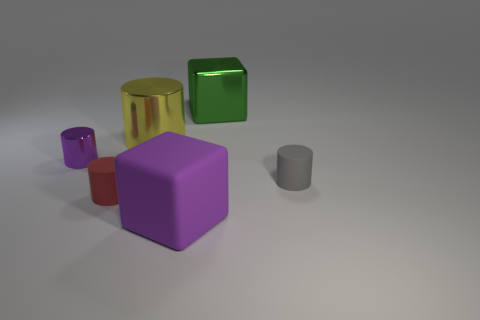What shape is the object that is to the right of the big rubber cube and behind the purple cylinder?
Offer a very short reply. Cube. There is a shiny object to the right of the purple rubber thing; what shape is it?
Your answer should be compact. Cube. How many cylinders are both to the left of the tiny gray matte cylinder and in front of the purple cylinder?
Keep it short and to the point. 1. Is the size of the red rubber cylinder the same as the cube in front of the big green shiny object?
Offer a very short reply. No. What is the size of the rubber object right of the large block in front of the metallic cube that is behind the large purple thing?
Give a very brief answer. Small. What is the size of the rubber cylinder that is to the right of the big green object?
Your answer should be very brief. Small. There is a gray thing that is the same material as the red object; what shape is it?
Offer a terse response. Cylinder. Are the big cube that is left of the green shiny thing and the gray thing made of the same material?
Your answer should be compact. Yes. What number of other objects are there of the same material as the green cube?
Provide a short and direct response. 2. What number of objects are either small cylinders to the right of the green object or big cubes that are behind the tiny metallic object?
Make the answer very short. 2. 